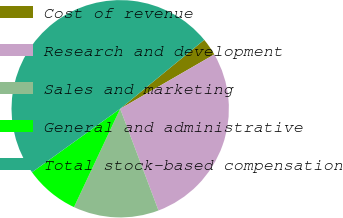<chart> <loc_0><loc_0><loc_500><loc_500><pie_chart><fcel>Cost of revenue<fcel>Research and development<fcel>Sales and marketing<fcel>General and administrative<fcel>Total stock-based compensation<nl><fcel>2.6%<fcel>27.6%<fcel>12.72%<fcel>8.08%<fcel>48.99%<nl></chart> 